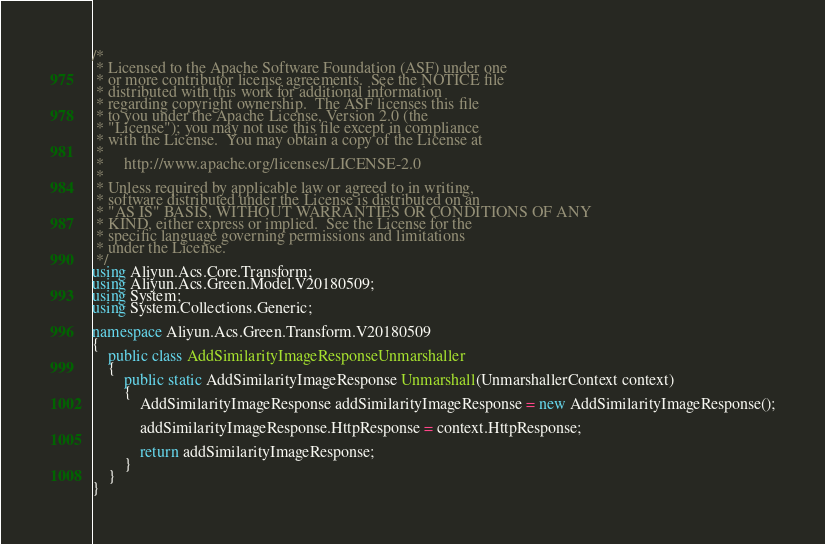<code> <loc_0><loc_0><loc_500><loc_500><_C#_>/*
 * Licensed to the Apache Software Foundation (ASF) under one
 * or more contributor license agreements.  See the NOTICE file
 * distributed with this work for additional information
 * regarding copyright ownership.  The ASF licenses this file
 * to you under the Apache License, Version 2.0 (the
 * "License"); you may not use this file except in compliance
 * with the License.  You may obtain a copy of the License at
 *
 *     http://www.apache.org/licenses/LICENSE-2.0
 *
 * Unless required by applicable law or agreed to in writing,
 * software distributed under the License is distributed on an
 * "AS IS" BASIS, WITHOUT WARRANTIES OR CONDITIONS OF ANY
 * KIND, either express or implied.  See the License for the
 * specific language governing permissions and limitations
 * under the License.
 */
using Aliyun.Acs.Core.Transform;
using Aliyun.Acs.Green.Model.V20180509;
using System;
using System.Collections.Generic;

namespace Aliyun.Acs.Green.Transform.V20180509
{
    public class AddSimilarityImageResponseUnmarshaller
    {
        public static AddSimilarityImageResponse Unmarshall(UnmarshallerContext context)
        {
			AddSimilarityImageResponse addSimilarityImageResponse = new AddSimilarityImageResponse();

			addSimilarityImageResponse.HttpResponse = context.HttpResponse;
        
			return addSimilarityImageResponse;
        }
    }
}</code> 